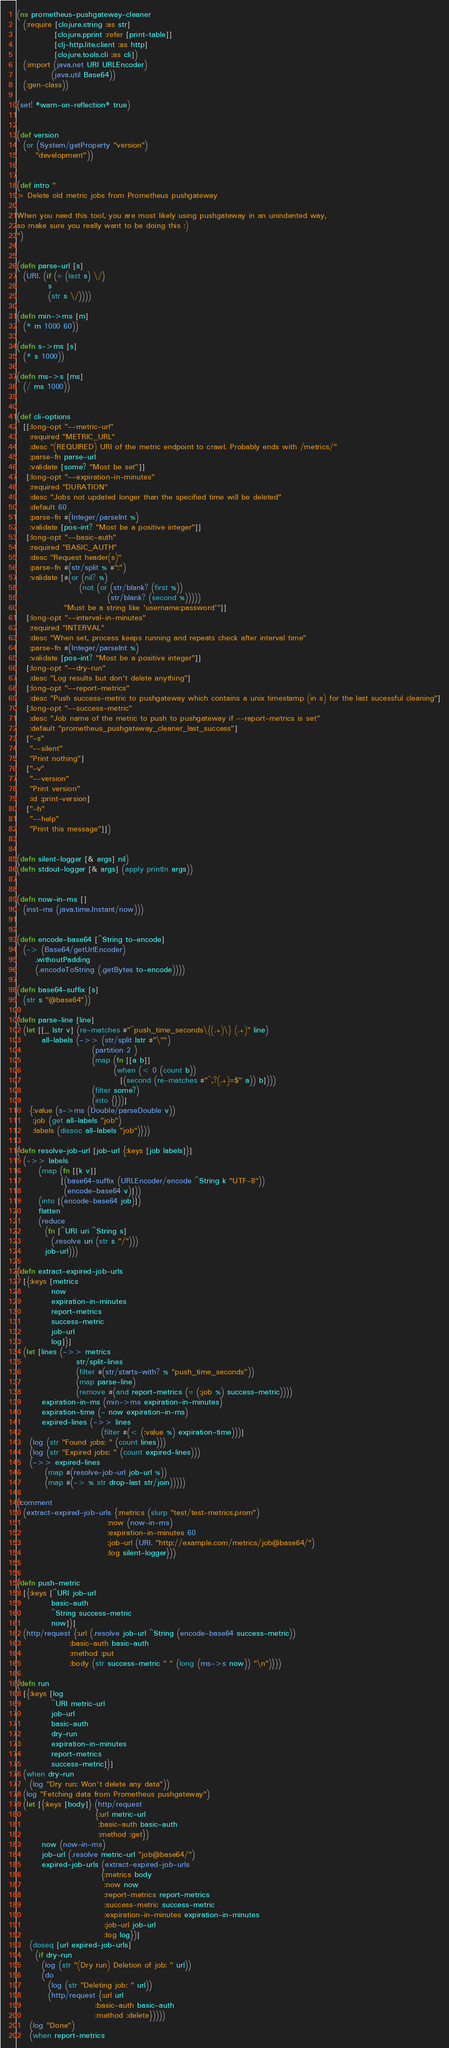<code> <loc_0><loc_0><loc_500><loc_500><_Clojure_>(ns prometheus-pushgateway-cleaner
  (:require [clojure.string :as str]
            [clojure.pprint :refer [print-table]]
            [clj-http.lite.client :as http]
            [clojure.tools.cli :as cli])
  (:import (java.net URI URLEncoder)
           (java.util Base64))
  (:gen-class))

(set! *warn-on-reflection* true)


(def version
  (or (System/getProperty "version")
      "development"))


(def intro "
> Delete old metric jobs from Prometheus pushgateway

When you need this tool, you are most likely using pushgateway in an unindented way,
so make sure you really want to be doing this :)
")


(defn parse-url [s]
  (URI. (if (= (last s) \/)
          s
          (str s \/))))

(defn min->ms [m]
  (* m 1000 60))

(defn s->ms [s]
  (* s 1000))

(defn ms->s [ms]
  (/ ms 1000))


(def cli-options
  [[:long-opt "--metric-url"
    :required "METRIC_URL"
    :desc "(REQUIRED) URI of the metric endpoint to crawl. Probably ends with /metrics/"
    :parse-fn parse-url
    :validate [some? "Most be set"]]
   [:long-opt "--expiration-in-minutes"
    :required "DURATION"
    :desc "Jobs not updated longer than the specified time will be deleted"
    :default 60
    :parse-fn #(Integer/parseInt %)
    :validate [pos-int? "Most be a positive integer"]]
   [:long-opt "--basic-auth"
    :required "BASIC_AUTH"
    :desc "Request header(s)"
    :parse-fn #(str/split % #":")
    :validate [#(or (nil? %)
                    (not (or (str/blank? (first %))
                             (str/blank? (second %)))))
               "Must be a string like 'username:password'"]]
   [:long-opt "--interval-in-minutes"
    :required "INTERVAL"
    :desc "When set, process keeps running and repeats check after interval time"
    :parse-fn #(Integer/parseInt %)
    :validate [pos-int? "Most be a positive integer"]]
   [:long-opt "--dry-run"
    :desc "Log results but don't delete anything"]
   [:long-opt "--report-metrics"
    :desc "Push success-metric to pushgateway which contains a unix timestamp (in s) for the last sucessful cleaning"]
   [:long-opt "--success-metric"
    :desc "Job name of the metric to push to pushgateway if --report-metrics is set"
    :default "prometheus_pushgateway_cleaner_last_success"]
   ["-s"
    "--silent"
    "Print nothing"]
   ["-v"
    "--version"
    "Print version"
    :id :print-version]
   ["-h"
    "--help"
    "Print this message"]])


(defn silent-logger [& args] nil)
(defn stdout-logger [& args] (apply println args))


(defn now-in-ms []
  (inst-ms (java.time.Instant/now)))


(defn encode-base64 [^String to-encode]
  (-> (Base64/getUrlEncoder)
      .withoutPadding
      (.encodeToString (.getBytes to-encode))))

(defn base64-suffix [s]
  (str s "@base64"))

(defn parse-line [line]
  (let [[_ lstr v] (re-matches #"^push_time_seconds\{(.+)\} (.+)" line)
        all-labels (->> (str/split lstr #"\"")
                        (partition 2 )
                        (map (fn [[a b]]
                               (when (< 0 (count b))
                                 [(second (re-matches #"^,?(.+)=$" a)) b])))
                        (filter some?)
                        (into {}))]
    {:value (s->ms (Double/parseDouble v))
     :job (get all-labels "job")
     :labels (dissoc all-labels "job")}))

(defn resolve-job-url [job-url {:keys [job labels]}]
  (->> labels
       (map (fn [[k v]]
              [(base64-suffix (URLEncoder/encode ^String k "UTF-8"))
               (encode-base64 v)]))
       (into [(encode-base64 job)])
       flatten
       (reduce
         (fn [^URI uri ^String s]
           (.resolve uri (str s "/")))
         job-url)))

(defn extract-expired-job-urls
  [{:keys [metrics
           now
           expiration-in-minutes
           report-metrics
           success-metric
           job-url
           log]}]
  (let [lines (->> metrics
                   str/split-lines
                   (filter #(str/starts-with? % "push_time_seconds"))
                   (map parse-line)
                   (remove #(and report-metrics (= (:job %) success-metric))))
        expiration-in-ms (min->ms expiration-in-minutes)
        expiration-time (- now expiration-in-ms)
        expired-lines (->> lines
                           (filter #(< (:value %) expiration-time)))]
    (log (str "Found jobs: " (count lines)))
    (log (str "Expired jobs: " (count expired-lines)))
    (->> expired-lines
         (map #(resolve-job-url job-url %))
         (map #(-> % str drop-last str/join)))))

(comment
  (extract-expired-job-urls {:metrics (slurp "test/test-metrics.prom")
                             :now (now-in-ms)
                             :expiration-in-minutes 60
                             :job-url (URI. "http://example.com/metrics/job@base64/")
                             :log silent-logger}))


(defn push-metric
  [{:keys [^URI job-url
           basic-auth
           ^String success-metric
           now]}]
  (http/request {:url (.resolve job-url ^String (encode-base64 success-metric))
                 :basic-auth basic-auth
                 :method :put
                 :body (str success-metric " " (long (ms->s now)) "\n")}))

(defn run
  [{:keys [log
           ^URI metric-url
           job-url
           basic-auth
           dry-run
           expiration-in-minutes
           report-metrics
           success-metric]}]
  (when dry-run
    (log "Dry run: Won't delete any data"))
  (log "Fetching data from Prometheus pushgateway")
  (let [{:keys [body]} (http/request
                         {:url metric-url
                          :basic-auth basic-auth
                          :method :get})
        now (now-in-ms)
        job-url (.resolve metric-url "job@base64/")
        expired-job-urls (extract-expired-job-urls
                           {:metrics body
                            :now now
                            :report-metrics report-metrics
                            :success-metric success-metric
                            :expiration-in-minutes expiration-in-minutes
                            :job-url job-url
                            :log log})]
    (doseq [url expired-job-urls]
      (if dry-run
        (log (str "(Dry run) Deletion of job: " url))
        (do
          (log (str "Deleting job: " url))
          (http/request {:url url
                         :basic-auth basic-auth
                         :method :delete}))))
    (log "Done")
    (when report-metrics</code> 